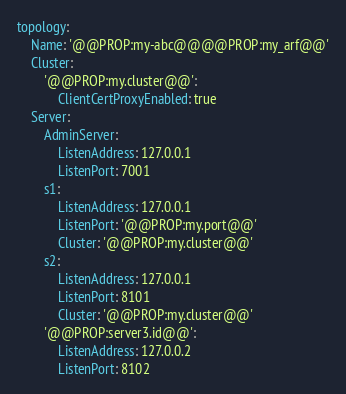Convert code to text. <code><loc_0><loc_0><loc_500><loc_500><_YAML_>topology:
    Name: '@@PROP:my-abc@@@@PROP:my_arf@@'
    Cluster:
        '@@PROP:my.cluster@@':
            ClientCertProxyEnabled: true
    Server:
        AdminServer:
            ListenAddress: 127.0.0.1
            ListenPort: 7001
        s1:
            ListenAddress: 127.0.0.1
            ListenPort: '@@PROP:my.port@@'
            Cluster: '@@PROP:my.cluster@@'
        s2:
            ListenAddress: 127.0.0.1
            ListenPort: 8101
            Cluster: '@@PROP:my.cluster@@'
        '@@PROP:server3.id@@':
            ListenAddress: 127.0.0.2
            ListenPort: 8102
</code> 